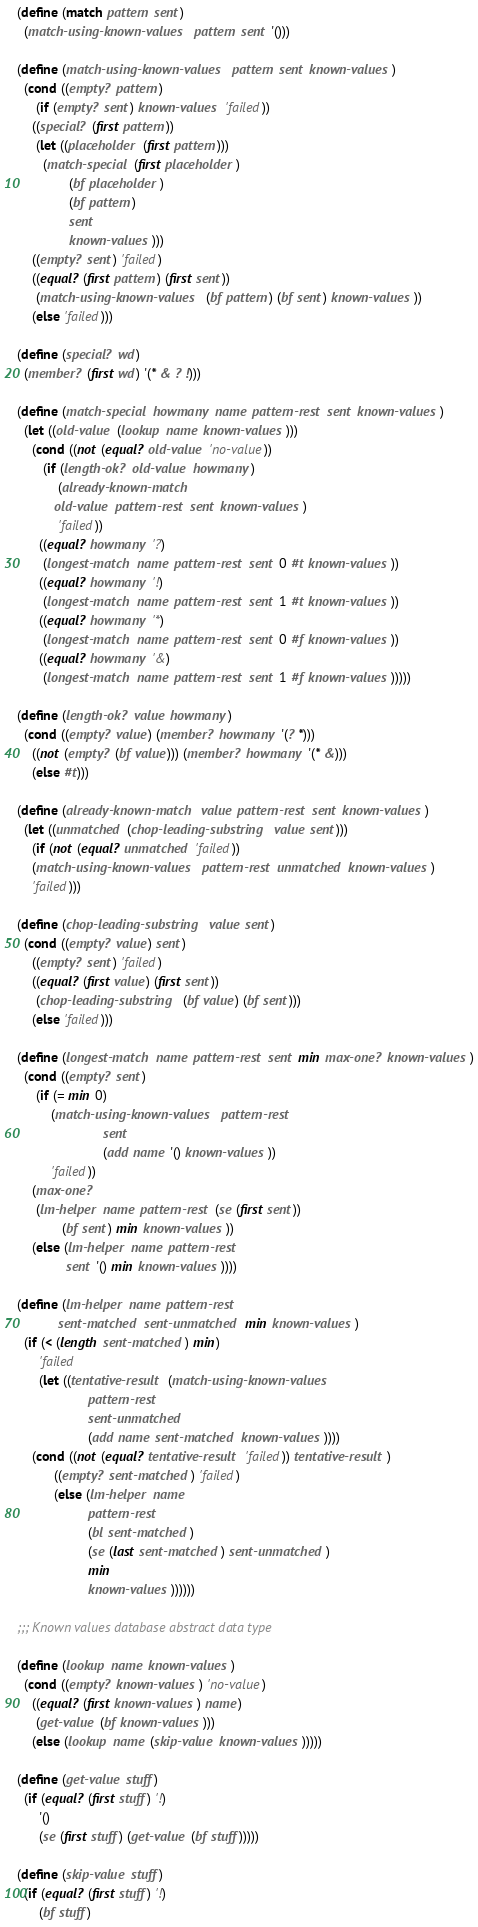Convert code to text. <code><loc_0><loc_0><loc_500><loc_500><_Scheme_>(define (match pattern sent)
  (match-using-known-values pattern sent '()))

(define (match-using-known-values pattern sent known-values)
  (cond ((empty? pattern)
	 (if (empty? sent) known-values 'failed))
	((special? (first pattern))
	 (let ((placeholder (first pattern)))
	   (match-special (first placeholder)
			  (bf placeholder)
			  (bf pattern)
			  sent
			  known-values)))
	((empty? sent) 'failed)
	((equal? (first pattern) (first sent))
	 (match-using-known-values (bf pattern) (bf sent) known-values))
	(else 'failed)))

(define (special? wd)
  (member? (first wd) '(* & ? !)))

(define (match-special howmany name pattern-rest sent known-values)
  (let ((old-value (lookup name known-values)))
    (cond ((not (equal? old-value 'no-value))
	   (if (length-ok? old-value howmany)
	       (already-known-match
		  old-value pattern-rest sent known-values)
	       'failed))
	  ((equal? howmany '?)
	   (longest-match name pattern-rest sent 0 #t known-values))
	  ((equal? howmany '!)
	   (longest-match name pattern-rest sent 1 #t known-values))
	  ((equal? howmany '*)
	   (longest-match name pattern-rest sent 0 #f known-values))
	  ((equal? howmany '&)
	   (longest-match name pattern-rest sent 1 #f known-values)))))

(define (length-ok? value howmany)
  (cond ((empty? value) (member? howmany '(? *)))
	((not (empty? (bf value))) (member? howmany '(* &)))
	(else #t)))

(define (already-known-match value pattern-rest sent known-values)
  (let ((unmatched (chop-leading-substring value sent)))
    (if (not (equal? unmatched 'failed))
	(match-using-known-values pattern-rest unmatched known-values)
	'failed)))

(define (chop-leading-substring value sent)
  (cond ((empty? value) sent)
	((empty? sent) 'failed)
	((equal? (first value) (first sent))
	 (chop-leading-substring (bf value) (bf sent)))
	(else 'failed)))

(define (longest-match name pattern-rest sent min max-one? known-values)
  (cond ((empty? sent)
	 (if (= min 0)
	     (match-using-known-values pattern-rest
				       sent
				       (add name '() known-values))
	     'failed))
	(max-one?
	 (lm-helper name pattern-rest (se (first sent))
		    (bf sent) min known-values))
	(else (lm-helper name pattern-rest
			 sent '() min known-values))))

(define (lm-helper name pattern-rest
		   sent-matched sent-unmatched min known-values)
  (if (< (length sent-matched) min)
      'failed
      (let ((tentative-result (match-using-known-values
			       pattern-rest
			       sent-unmatched
			       (add name sent-matched known-values))))
	(cond ((not (equal? tentative-result 'failed)) tentative-result)
	      ((empty? sent-matched) 'failed)
	      (else (lm-helper name
			       pattern-rest
			       (bl sent-matched)
			       (se (last sent-matched) sent-unmatched)
			       min
			       known-values))))))

;;; Known values database abstract data type

(define (lookup name known-values)
  (cond ((empty? known-values) 'no-value)
	((equal? (first known-values) name)
	 (get-value (bf known-values)))
	(else (lookup name (skip-value known-values)))))

(define (get-value stuff)
  (if (equal? (first stuff) '!)
      '()
      (se (first stuff) (get-value (bf stuff)))))

(define (skip-value stuff)
  (if (equal? (first stuff) '!)
      (bf stuff)</code> 